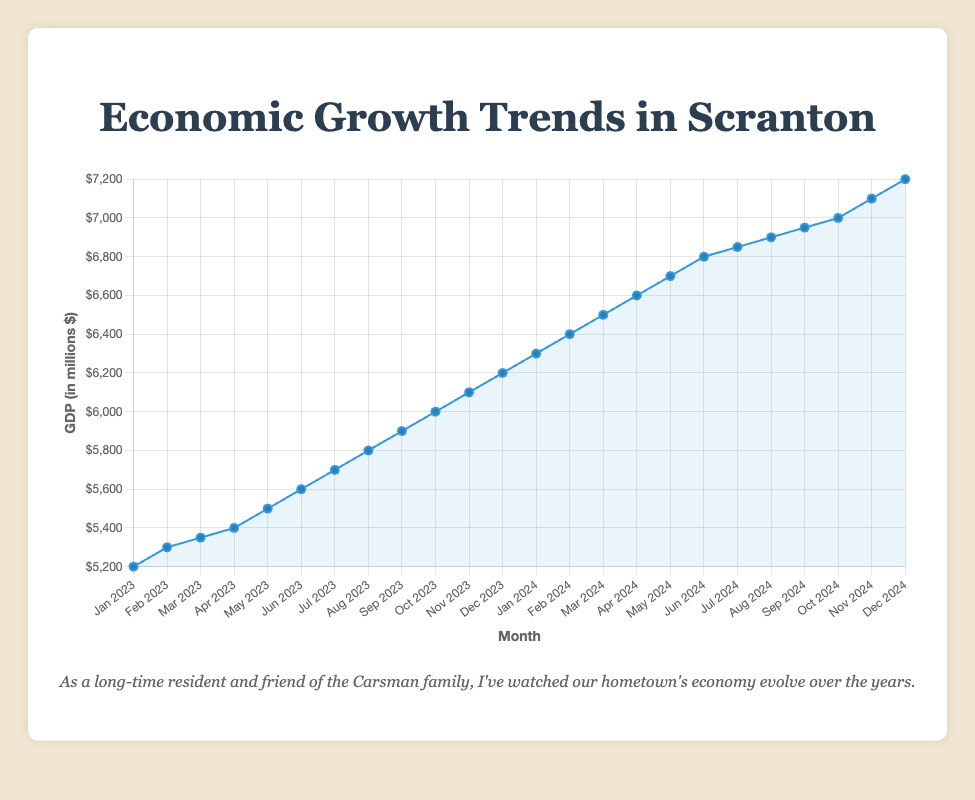When did Scranton's GDP surpass $6000 million? To determine when Scranton's GDP surpassed $6000 million, locate the point on the line plot where the GDP value crosses above $6000. The line crosses $6000 in October 2023.
Answer: October 2023 How much did Scranton's GDP increase from the beginning of 2023 to the end of 2024? To find the increase, subtract the GDP value at the start of 2023 (January 2023) from the GDP value at the end of 2024 (December 2024). The values are $5200 million and $7200 million, respectively. So, $7200 - $5200 = $2000 million.
Answer: $2000 million What is the average monthly GDP for Scranton in 2023? Calculate the average GDP for 2023 by summing up the monthly GDP values for each month in 2023 and dividing by 12. The sum is $71400 million, so the average monthly GDP is $71400 / 12 = $5950 million.
Answer: $5950 million Between which two months in 2024 did Scranton see the largest increase in GDP? To identify the largest increase, compare the GDP differences between successive months in 2024. The largest increase is between January 2024 and February 2024, where the GDP increased by $6400 - $6300 = $100 million.
Answer: January 2024 and February 2024 Is there any month where Scranton's GDP remains steady without an increase? Examine the line plot for any month-to-month flat sections where GDP values are the same. From the data, there are no months where Scranton's GDP remains steady without any increase.
Answer: No What is the median GDP value for Scranton from January 2023 to December 2024? To find the median GDP, first, list all monthly GDP values in order and then find the middle value(s). Since there are 24 data points, the median will be the average of the 12th and 13th values. The values are $6100 million and $6300 million, thus the median is ($6100 + $6300) / 2 = $6200 million.
Answer: $6200 million How much did Scranton's GDP grow from July 2023 to July 2024? Subtract the GDP value of July 2023 from July 2024. The values are $5700 million and $6850 million, respectively. So, $6850 - $5700 = $1150 million.
Answer: $1150 million Compare the GDP growth in the first half of 2023 to the second half. Which period had a higher increase? Sum the GDP values from January to June 2023 and from July to December 2023 and find the difference. The growth in the first half is $5600 - $5200 = $400 million and the second half is $6200 - $5700 = $500 million. The second half saw a higher increase.
Answer: Second half of 2023 What is the overall trend observed in Scranton's GDP from January 2023 to December 2024? Evaluate the line plot's general progression. It shows a consistent upward trend.
Answer: Consistent upward trend 